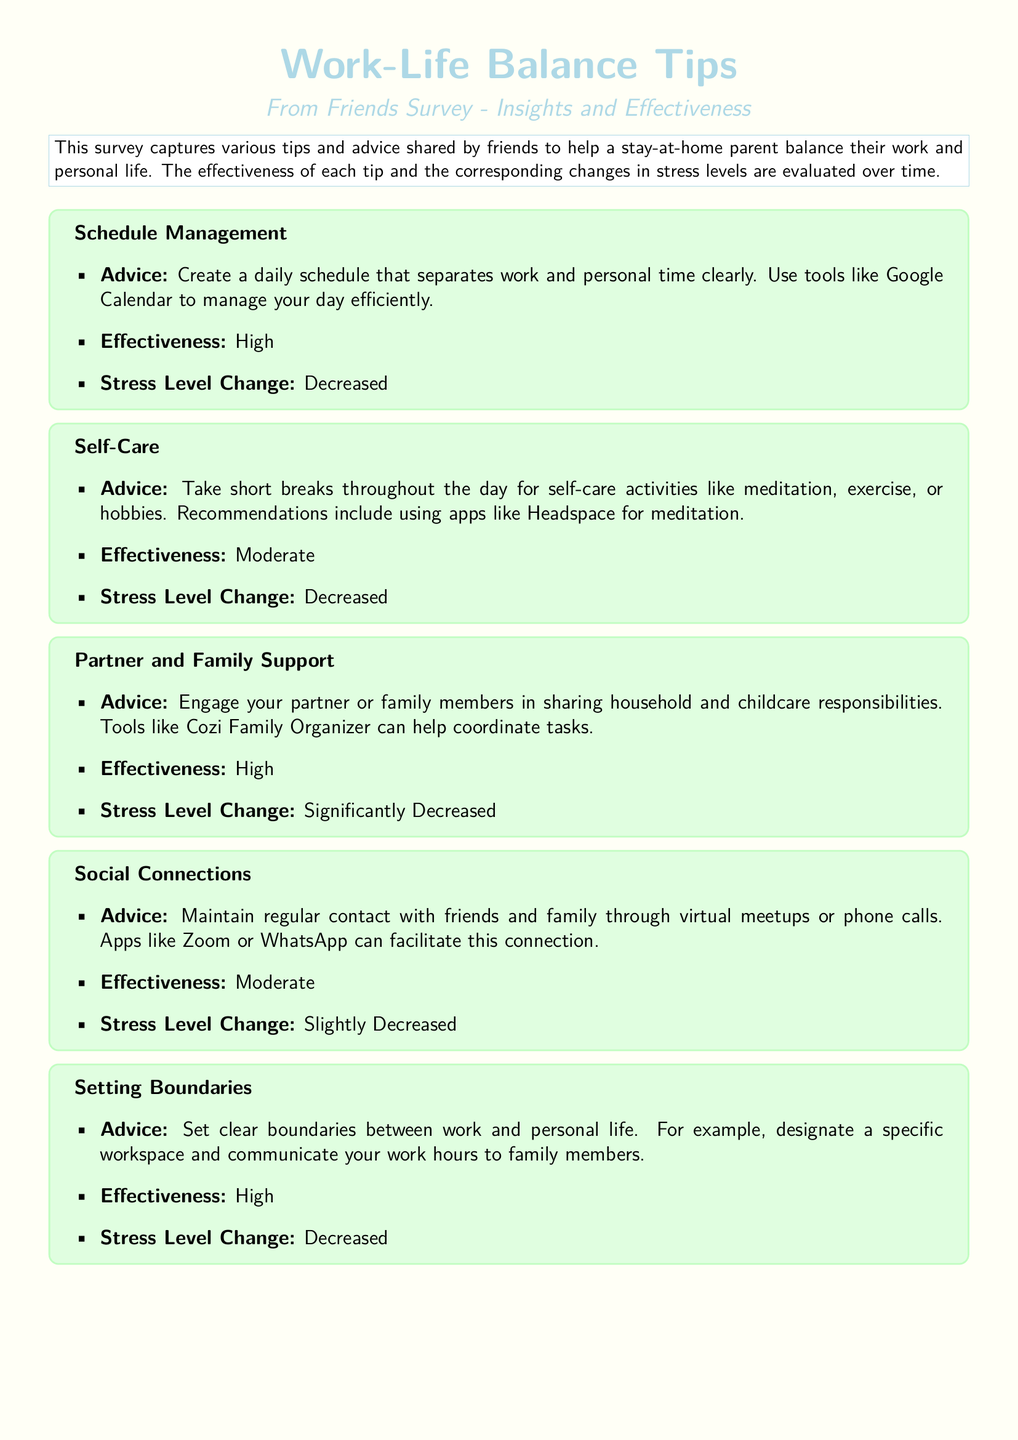What is the first tip mentioned? The first tip listed in the survey is about creating a daily schedule to separate work and personal time.
Answer: Schedule Management What tool is recommended for schedule management? The document suggests using Google Calendar for efficient schedule management.
Answer: Google Calendar How effective is the partner and family support tip? The effectiveness of engaging partner or family members for shared responsibilities is rated as high.
Answer: High What was the change in stress level after implementing self-care activities? The document mentions that the stress level after self-care activities decreased.
Answer: Decreased What platform is suggested for seeking professional help? The document recommends using BetterHelp for online counseling services.
Answer: BetterHelp How many tips are listed in total? The total number of tips shared in the survey is six.
Answer: Six What color is used for the main title in the document? The color used for the main title is pastel blue.
Answer: Pastel blue Which tip had a varied effectiveness rating? The tip regarding professional help had a varied effectiveness rating in the document.
Answer: Professional Help What is the overall conclusion regarding the tips? The overall conclusion indicates that a combination of strategies resulted in the greatest reduction in stress levels.
Answer: Combination of strategies 